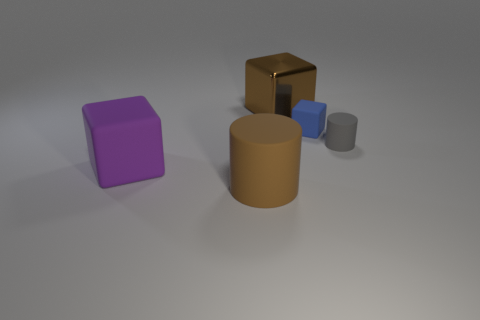Subtract all tiny blue blocks. How many blocks are left? 2 Add 4 shiny cubes. How many objects exist? 9 Subtract all cylinders. How many objects are left? 3 Subtract all blue blocks. How many blocks are left? 2 Subtract all gray cylinders. Subtract all green blocks. How many cylinders are left? 1 Subtract all big blue metal cubes. Subtract all rubber blocks. How many objects are left? 3 Add 2 small gray cylinders. How many small gray cylinders are left? 3 Add 2 big purple matte cubes. How many big purple matte cubes exist? 3 Subtract 0 cyan blocks. How many objects are left? 5 